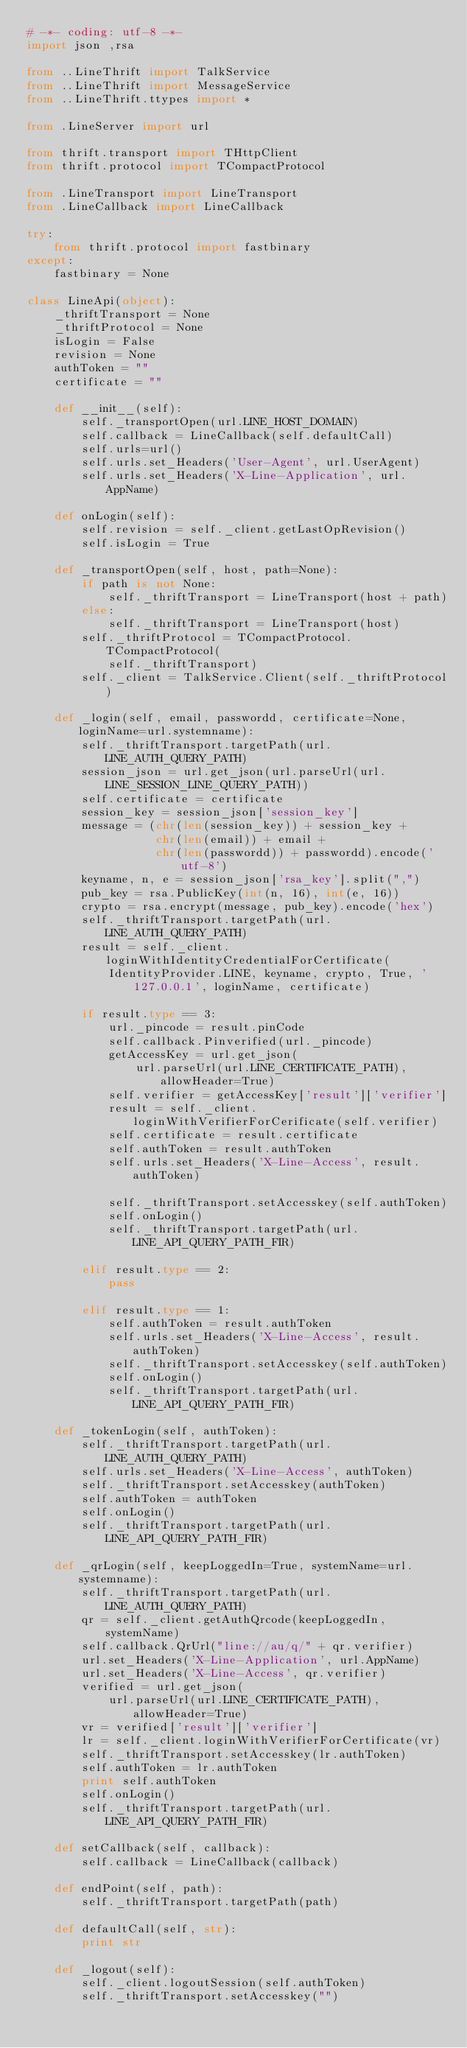Convert code to text. <code><loc_0><loc_0><loc_500><loc_500><_Python_># -*- coding: utf-8 -*-
import json ,rsa

from ..LineThrift import TalkService
from ..LineThrift import MessageService
from ..LineThrift.ttypes import *

from .LineServer import url

from thrift.transport import THttpClient
from thrift.protocol import TCompactProtocol

from .LineTransport import LineTransport
from .LineCallback import LineCallback

try:
    from thrift.protocol import fastbinary
except:
    fastbinary = None

class LineApi(object):
    _thriftTransport = None
    _thriftProtocol = None
    isLogin = False
    revision = None
    authToken = ""
    certificate = ""

    def __init__(self):
        self._transportOpen(url.LINE_HOST_DOMAIN)
        self.callback = LineCallback(self.defaultCall)
        self.urls=url()
        self.urls.set_Headers('User-Agent', url.UserAgent)
        self.urls.set_Headers('X-Line-Application', url.AppName)

    def onLogin(self):
        self.revision = self._client.getLastOpRevision()
        self.isLogin = True

    def _transportOpen(self, host, path=None):
        if path is not None:
            self._thriftTransport = LineTransport(host + path)
        else:
            self._thriftTransport = LineTransport(host)
        self._thriftProtocol = TCompactProtocol.TCompactProtocol(
            self._thriftTransport)
        self._client = TalkService.Client(self._thriftProtocol)

    def _login(self, email, passwordd, certificate=None, loginName=url.systemname):
        self._thriftTransport.targetPath(url.LINE_AUTH_QUERY_PATH)
        session_json = url.get_json(url.parseUrl(url.LINE_SESSION_LINE_QUERY_PATH))
        self.certificate = certificate
        session_key = session_json['session_key']
        message = (chr(len(session_key)) + session_key +
                   chr(len(email)) + email +
                   chr(len(passwordd)) + passwordd).encode('utf-8')
        keyname, n, e = session_json['rsa_key'].split(",")
        pub_key = rsa.PublicKey(int(n, 16), int(e, 16))
        crypto = rsa.encrypt(message, pub_key).encode('hex')
        self._thriftTransport.targetPath(url.LINE_AUTH_QUERY_PATH)
        result = self._client.loginWithIdentityCredentialForCertificate(
            IdentityProvider.LINE, keyname, crypto, True, '127.0.0.1', loginName, certificate)

        if result.type == 3:
            url._pincode = result.pinCode
            self.callback.Pinverified(url._pincode)
            getAccessKey = url.get_json(
                url.parseUrl(url.LINE_CERTIFICATE_PATH), allowHeader=True)
            self.verifier = getAccessKey['result']['verifier']
            result = self._client.loginWithVerifierForCerificate(self.verifier)
            self.certificate = result.certificate
            self.authToken = result.authToken
            self.urls.set_Headers('X-Line-Access', result.authToken)

            self._thriftTransport.setAccesskey(self.authToken)
            self.onLogin()
            self._thriftTransport.targetPath(url.LINE_API_QUERY_PATH_FIR)

        elif result.type == 2:
            pass

        elif result.type == 1:
            self.authToken = result.authToken
            self.urls.set_Headers('X-Line-Access', result.authToken)
            self._thriftTransport.setAccesskey(self.authToken)
            self.onLogin()
            self._thriftTransport.targetPath(url.LINE_API_QUERY_PATH_FIR)

    def _tokenLogin(self, authToken):
        self._thriftTransport.targetPath(url.LINE_AUTH_QUERY_PATH)
        self.urls.set_Headers('X-Line-Access', authToken)
        self._thriftTransport.setAccesskey(authToken)
        self.authToken = authToken
        self.onLogin()
        self._thriftTransport.targetPath(url.LINE_API_QUERY_PATH_FIR)

    def _qrLogin(self, keepLoggedIn=True, systemName=url.systemname):
        self._thriftTransport.targetPath(url.LINE_AUTH_QUERY_PATH)
        qr = self._client.getAuthQrcode(keepLoggedIn, systemName)
        self.callback.QrUrl("line://au/q/" + qr.verifier)
        url.set_Headers('X-Line-Application', url.AppName)
        url.set_Headers('X-Line-Access', qr.verifier)
        verified = url.get_json(
            url.parseUrl(url.LINE_CERTIFICATE_PATH), allowHeader=True)
        vr = verified['result']['verifier']
        lr = self._client.loginWithVerifierForCertificate(vr)
        self._thriftTransport.setAccesskey(lr.authToken)
        self.authToken = lr.authToken
        print self.authToken
        self.onLogin()
        self._thriftTransport.targetPath(url.LINE_API_QUERY_PATH_FIR)

    def setCallback(self, callback):
        self.callback = LineCallback(callback)

    def endPoint(self, path):
        self._thriftTransport.targetPath(path)

    def defaultCall(self, str):
        print str

    def _logout(self):
        self._client.logoutSession(self.authToken)
        self._thriftTransport.setAccesskey("")
</code> 